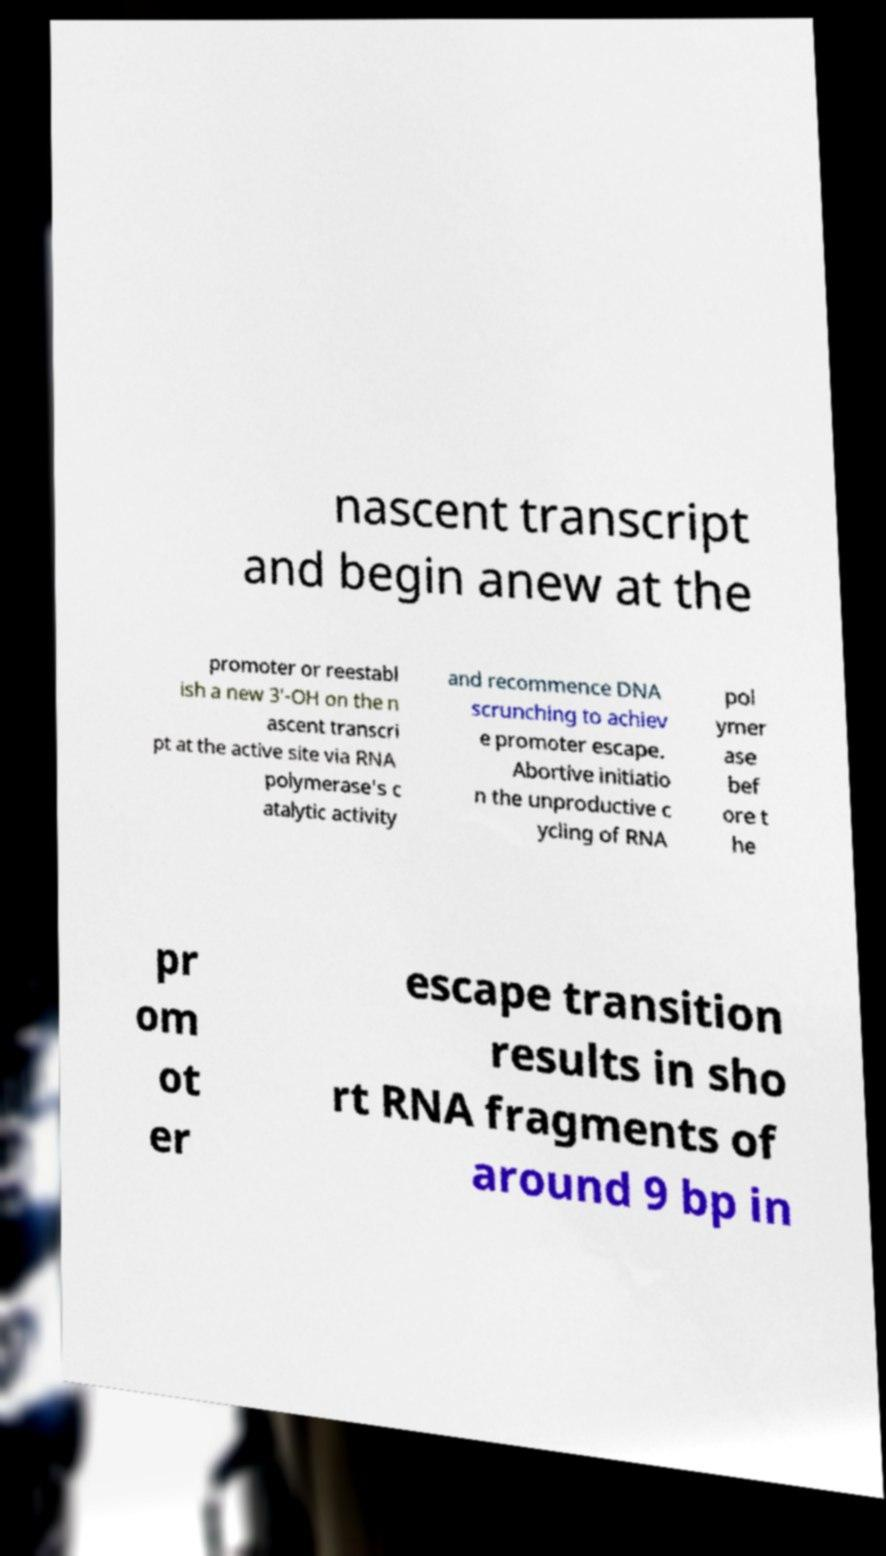I need the written content from this picture converted into text. Can you do that? nascent transcript and begin anew at the promoter or reestabl ish a new 3′-OH on the n ascent transcri pt at the active site via RNA polymerase's c atalytic activity and recommence DNA scrunching to achiev e promoter escape. Abortive initiatio n the unproductive c ycling of RNA pol ymer ase bef ore t he pr om ot er escape transition results in sho rt RNA fragments of around 9 bp in 